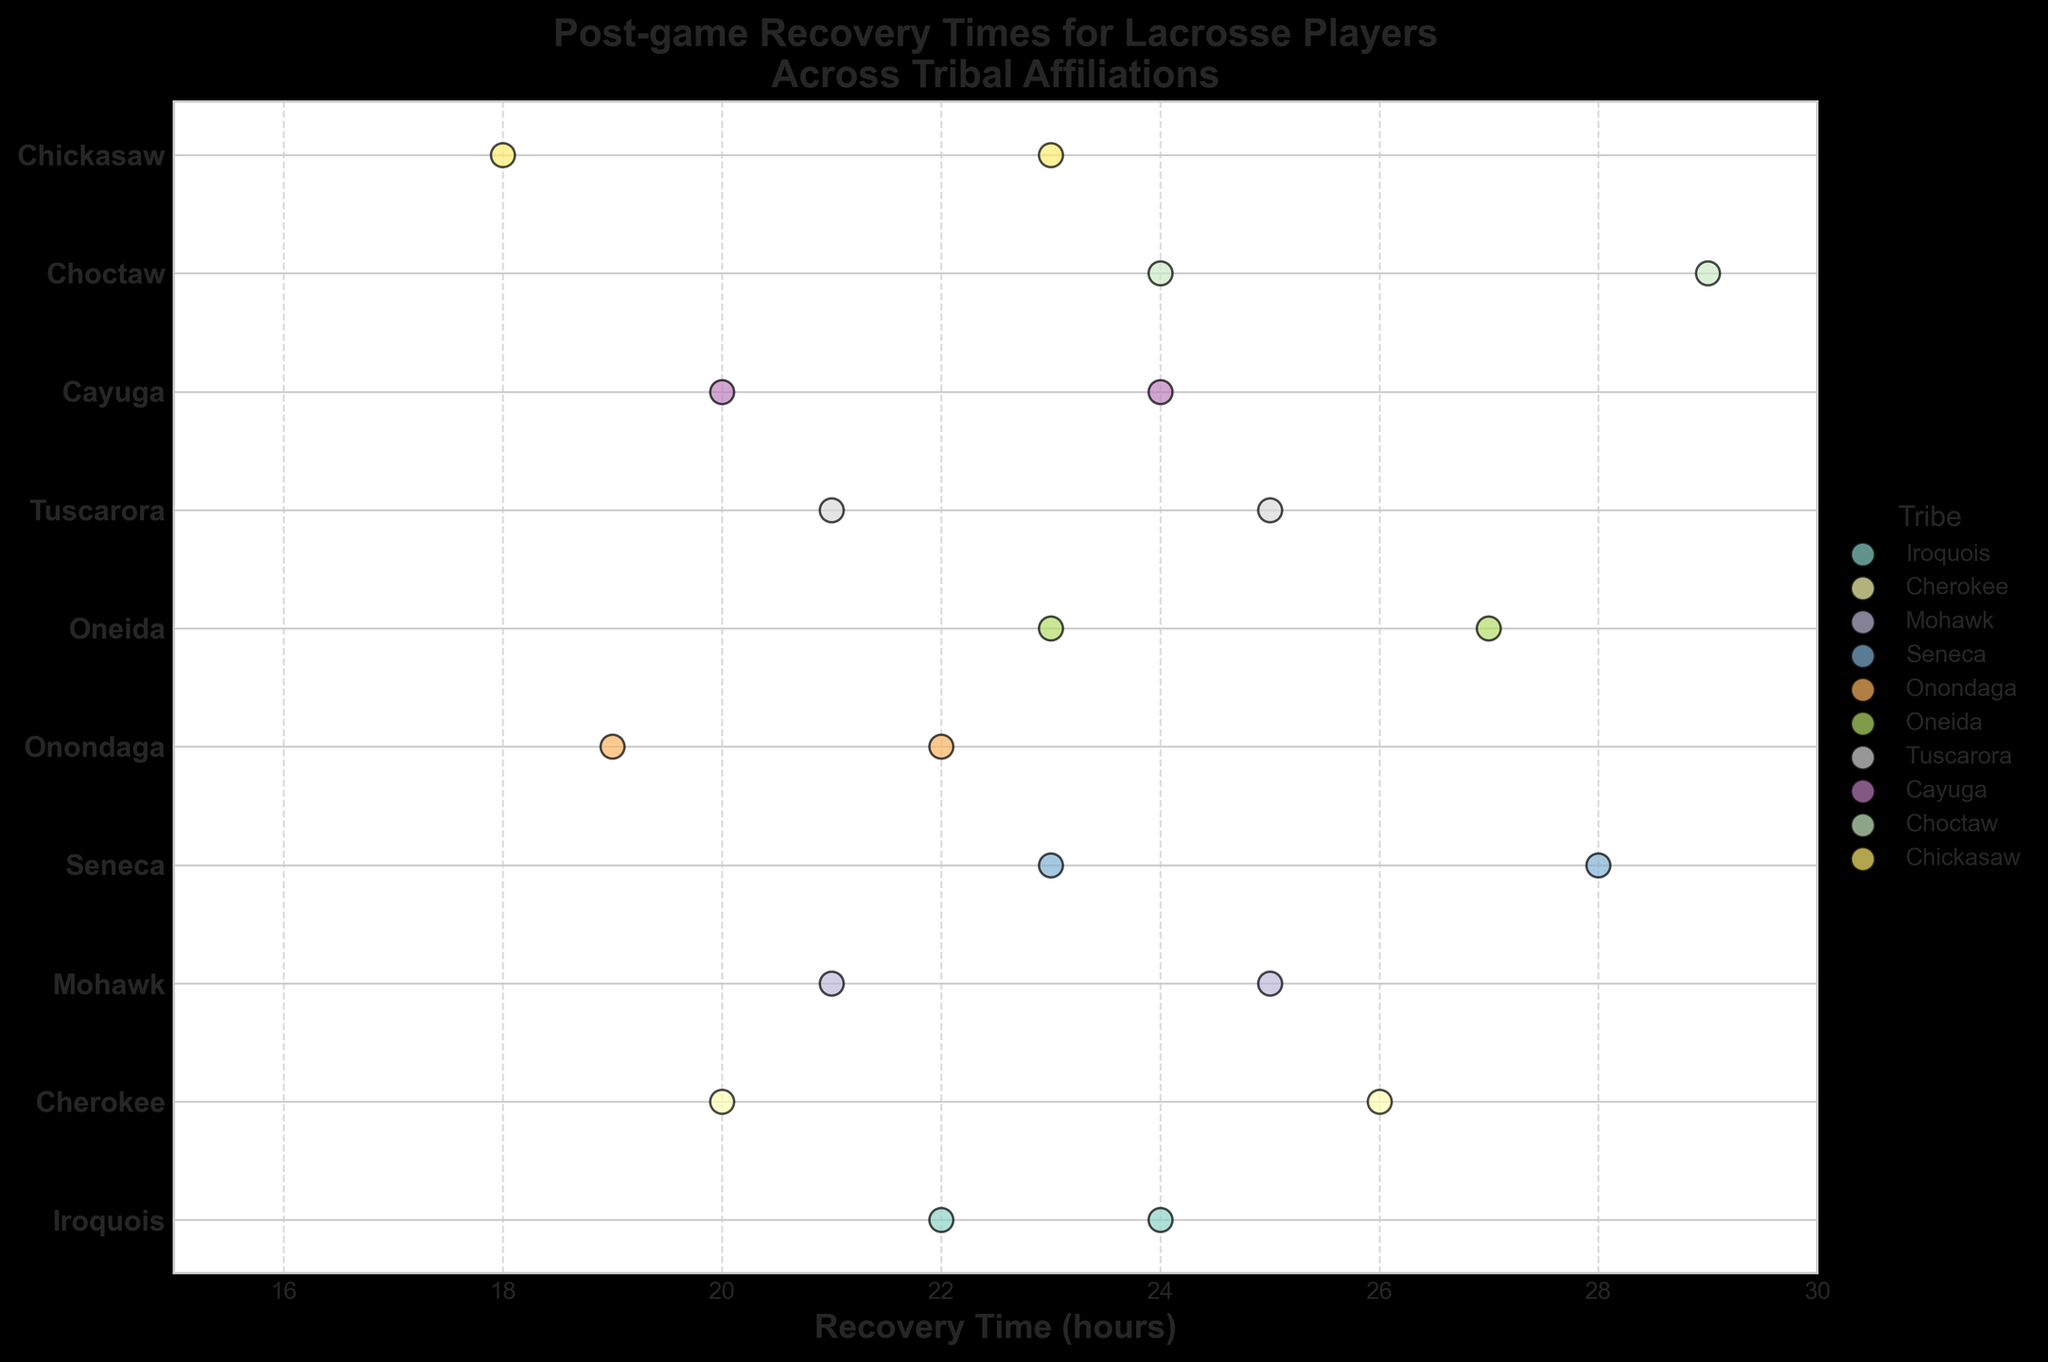What is the title of the figure? The title is usually located at the top of the figure. It provides a brief summary of what the graph represents.
Answer: Post-game Recovery Times for Lacrosse Players Across Tribal Affiliations Which tribe has the recovery time of 29 hours? By locating the recovery time of 29 hours, we can see which tribe's data point it corresponds to on the y-axis.
Answer: Choctaw What is the range of recovery times shown in the figure? The minimum recovery time is 18 hours and the maximum recovery time is 29 hours. This range can be observed from the x-axis of the figure.
Answer: 18 to 29 hours Which tribe has the most data points? By counting the number of data points for each tribe on the y-axis, we can determine which tribe has the most.
Answer: All tribes have 2 data points What is the median recovery time for the Onondaga tribe? The recovery times for Onondaga are 19 and 22. The median is the middle value of these sorted numbers.
Answer: 20.5 hours Which tribe has the lowest recovery time? By identifying the lowest value on the x-axis and seeing which tribe's data point it corresponds to on the y-axis.
Answer: Chickasaw What is the average recovery time for the Iroquois tribe? The recovery times for Iroquois are 24 and 22. Adding them gives 46 and dividing by the number of data points (2) gives 23.
Answer: 23 hours How many tribes have an average recovery time above 24 hours? Calculate the average for each tribe and count how many of these averages are above 24. Iroquois (23), Cherokee (23), Mohawk (23), Seneca (25.5), Onondaga (20.5), Oneida (25), Tuscarora (23), Cayuga (22), Choctaw (26.5), Chickasaw (20.5).
Answer: 3 tribes: Oneida, Seneca, and Choctaw Which tribes have players with a recovery time of 24 hours? By identifying the data points located at 24 hours on the x-axis and seeing which tribes they correspond to.
Answer: Iroquois, Cayuga, Choctaw Which tribe shows a greater variation in recovery times, Seneca or Mohawk? Seneca has recovery times of 28 and 23 with a range of 5 hours. Mohawk has recovery times of 25 and 21 with a range of 4 hours.
Answer: Seneca 